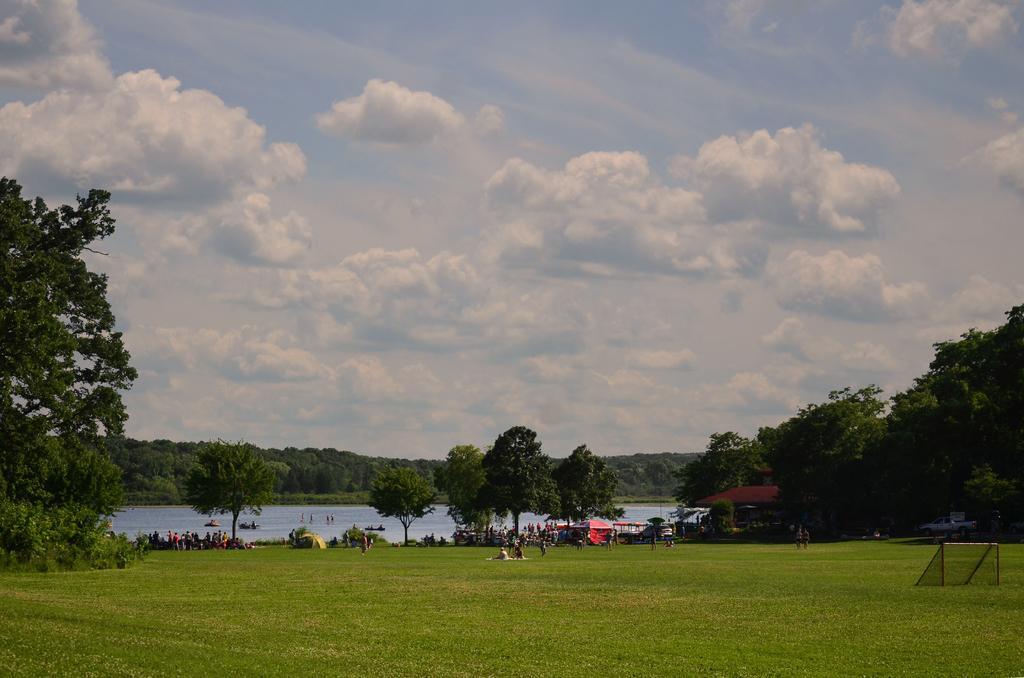Describe this image in one or two sentences. In this image I can see some grass, few trees, few persons, a car and few tents. In the background I can see some water, few trees and the sky. 